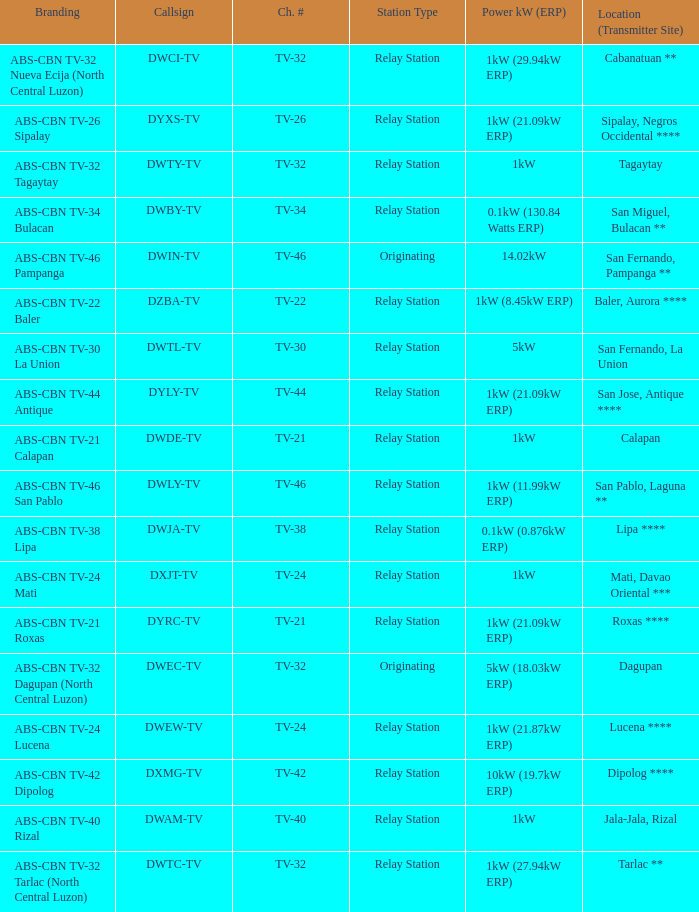What is the branding of the callsign DWCI-TV? ABS-CBN TV-32 Nueva Ecija (North Central Luzon). 